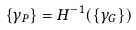<formula> <loc_0><loc_0><loc_500><loc_500>\{ \gamma _ { P } \} = H ^ { - 1 } ( \{ \gamma _ { G } \} )</formula> 